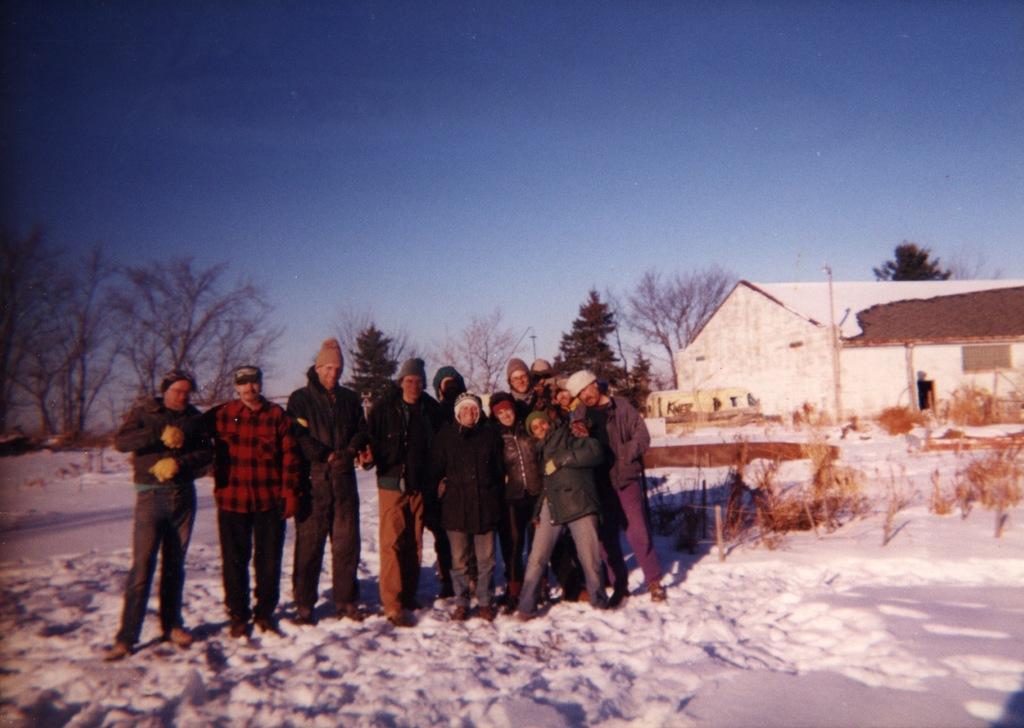Can you describe this image briefly? In this picture we can see some people standing here, at the bottom there is snow, we can see a house on the right side, in the background there are some trees, we can see the sky at the top of the picture. 